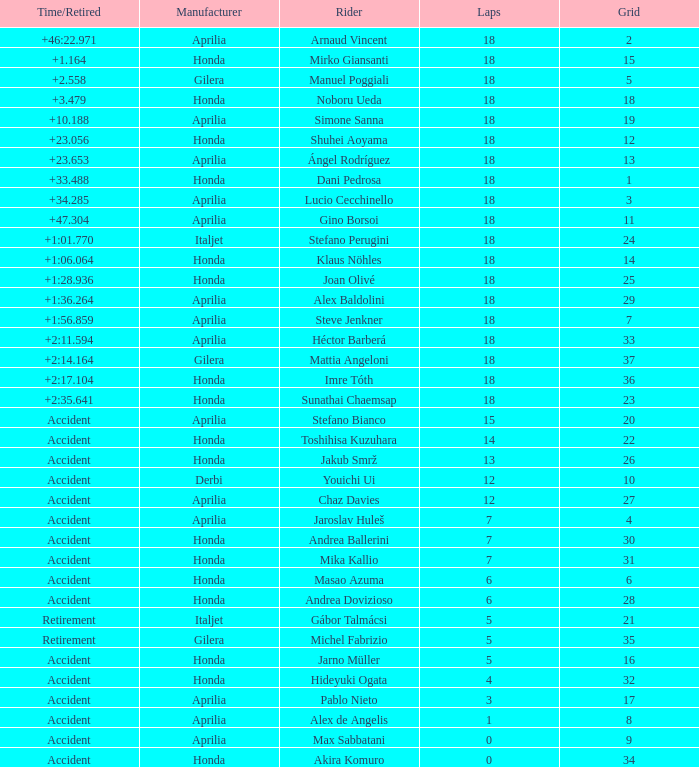Who is the rider with less than 15 laps, more than 32 grids, and an accident time/retired? Akira Komuro. 